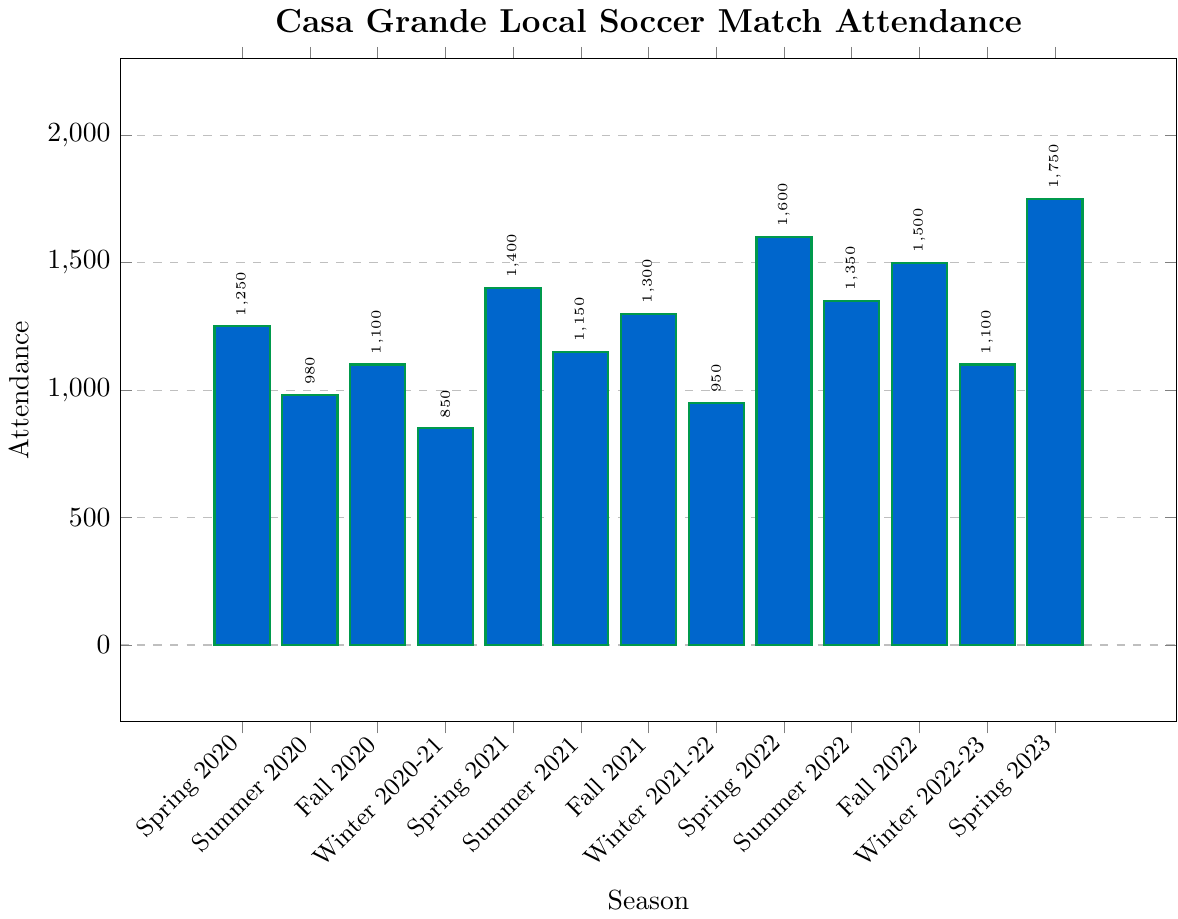Which season had the highest attendance? Look for the tallest bar in the plot, indicating the highest attendance. The tallest bar corresponds to Spring 2023.
Answer: Spring 2023 Which season had the lowest attendance in 2020? Compare the heights of the bars corresponding to the 2020 seasons: Spring, Summer, Fall, and Winter 2020-21. The shortest bar is for Winter 2020-21.
Answer: Winter 2020-21 What is the average attendance for the four winter seasons? Calculate the average of the attendance figures for Winter 2020-21 (850), Winter 2021-22 (950), Winter 2022-23 (1100), and Winter 2023 (not listed). The average is (850 + 950 + 1100) / 3 = 966.7.
Answer: 966.7 How does the attendance in Spring 2023 compare to Spring 2020? Compare the heights of the bars for Spring 2023 and Spring 2020. The bar for Spring 2023 is taller than that for Spring 2020. The specific attendances are 1750 and 1250 respectively.
Answer: Spring 2023 is higher Which season had the smallest increase in attendance compared to the previous season? Calculate the differences in attendance between each subsequent pair of seasons and identify the smallest difference. The smallest positive difference is between Fall 2020 and Winter 2020-21 (1100 - 850 = 250).
Answer: Winter 2020-21 Is there a general trend in the attendance figures from 2020 to 2023? Observe the overall pattern in the bar heights from Spring 2020 to Spring 2023. There is a general increasing trend in attendance over the years, especially noticeable in the Spring seasons.
Answer: Increasing trend What is the sum of attendance for all Spring seasons? Sum the attendance figures for Spring 2020 (1250), Spring 2021 (1400), Spring 2022 (1600), and Spring 2023 (1750). The total is 1250 + 1400 + 1600 + 1750 = 6000.
Answer: 6000 By how much did the attendance change from Fall 2022 to Winter 2022-23? Subtract the attendance for Winter 2022-23 (1100) from the attendance for Fall 2022 (1500). The difference is 1500 - 1100 = 400.
Answer: 400 Which seasons have attendance figures above 1500? Identify bars that exceed the 1500 mark on the y-axis. The seasons are Spring 2022 (1600) and Spring 2023 (1750).
Answer: Spring 2022 and Spring 2023 